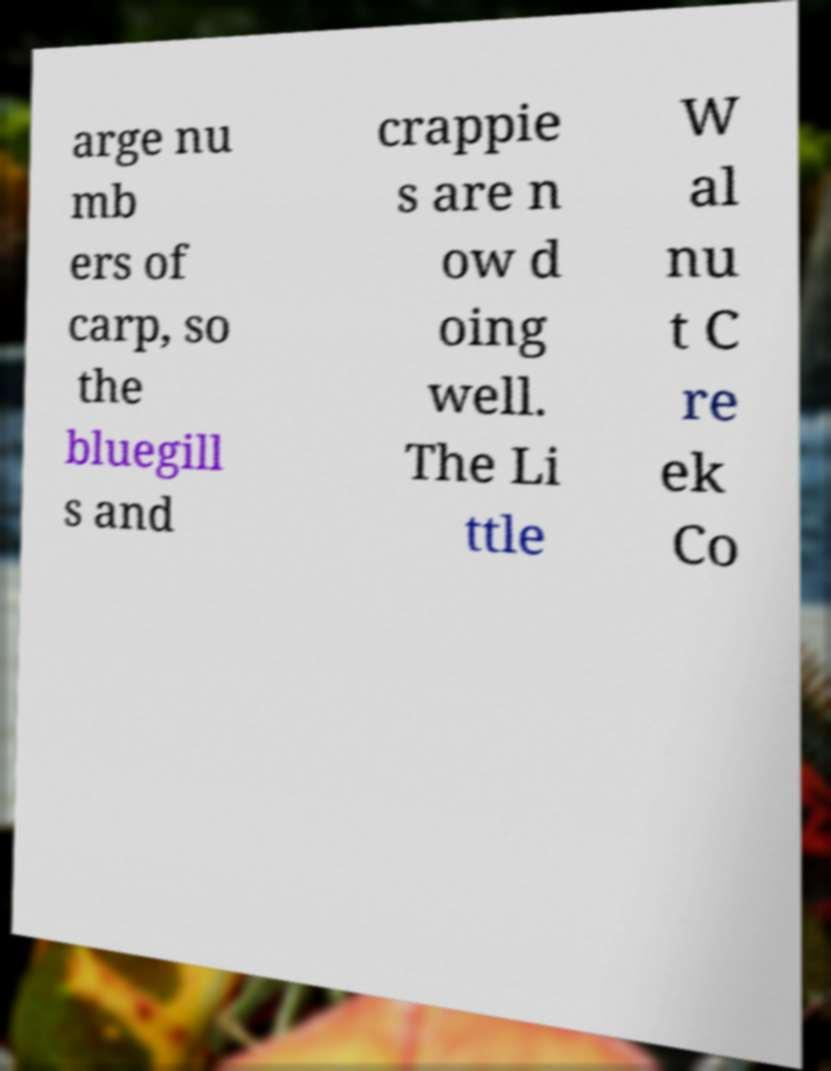For documentation purposes, I need the text within this image transcribed. Could you provide that? arge nu mb ers of carp, so the bluegill s and crappie s are n ow d oing well. The Li ttle W al nu t C re ek Co 